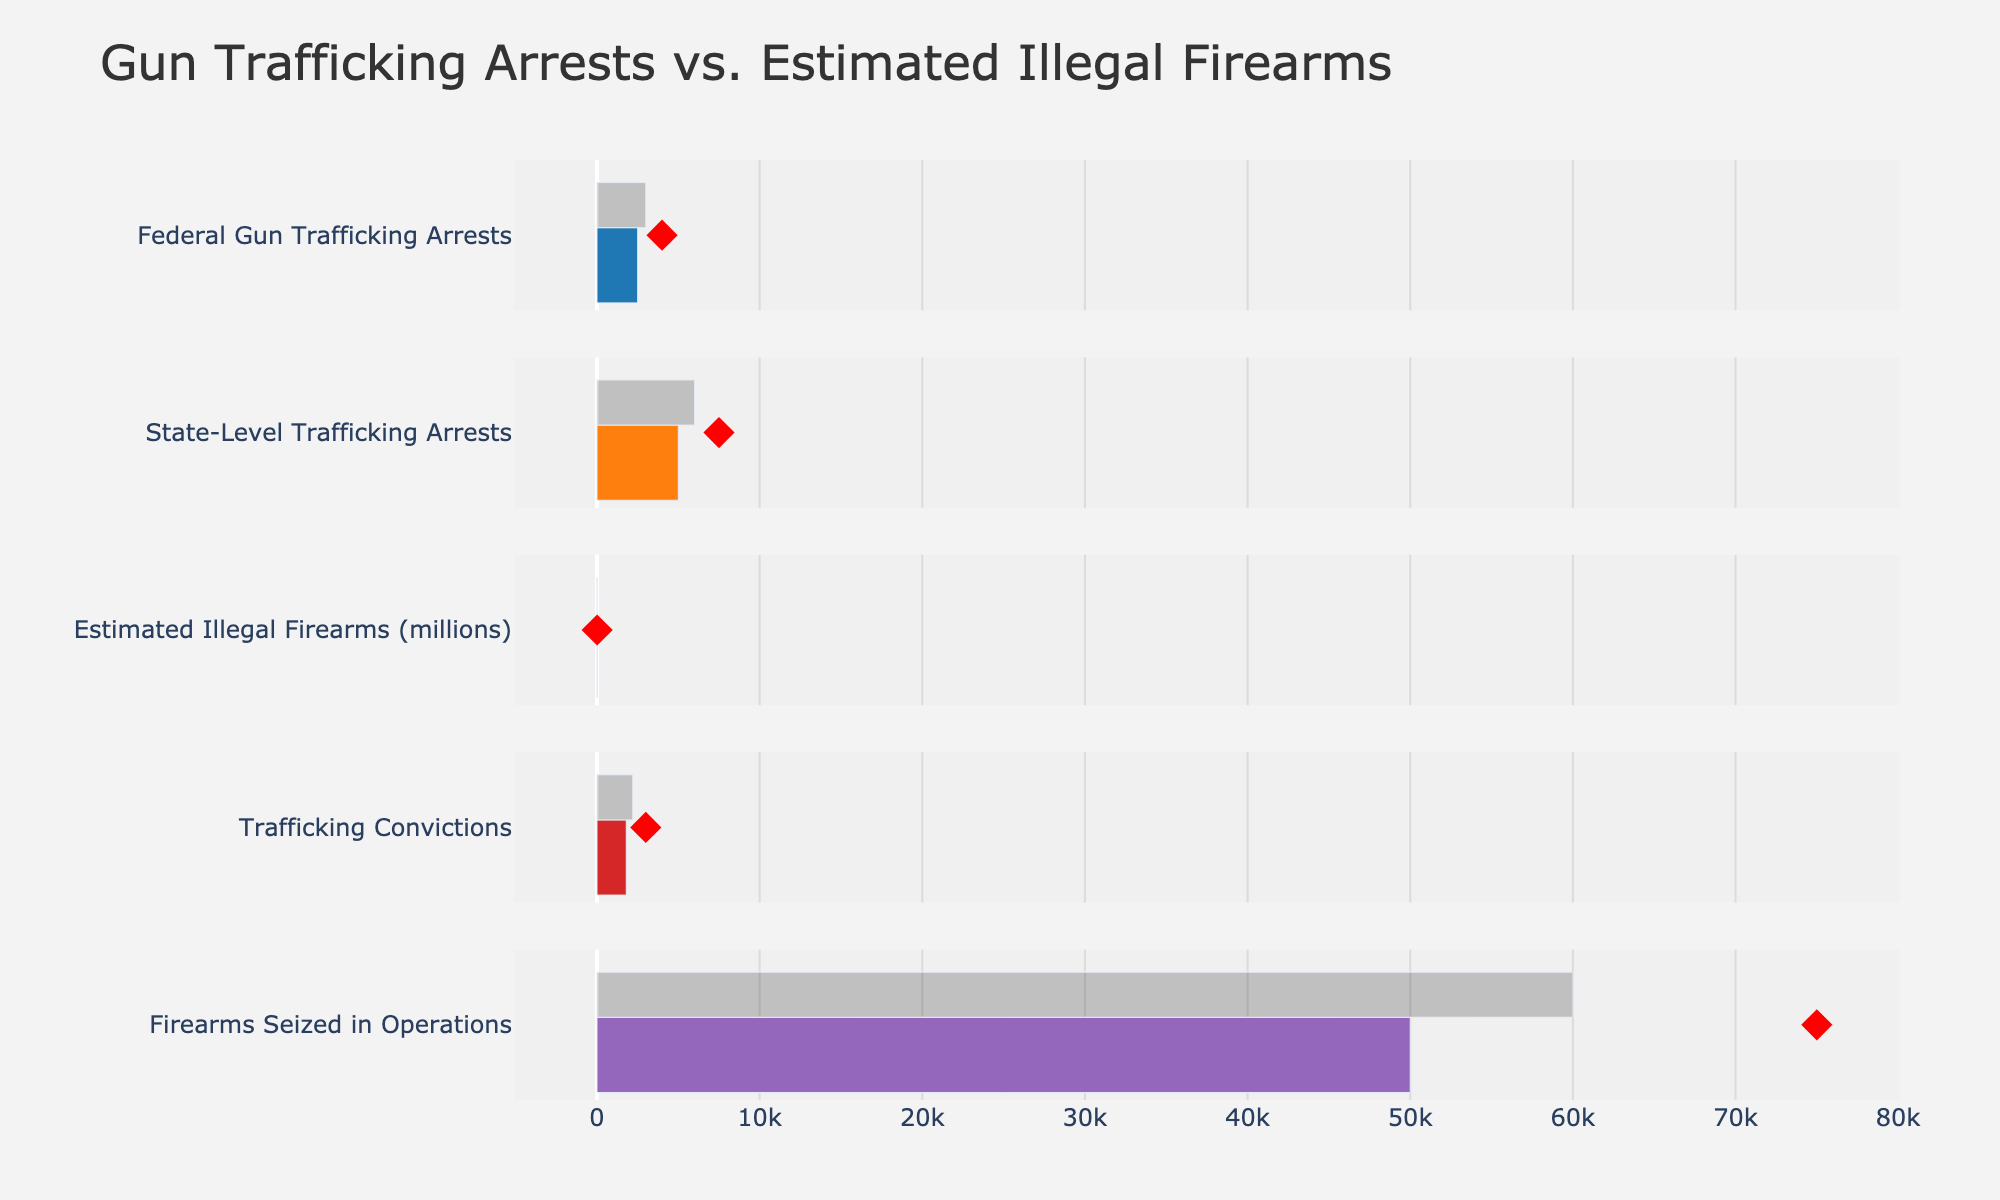what is the title of the figure? The title is displayed at the top of the figure. It's a clear descriptive text for the entire chart.
Answer: Gun Trafficking Arrests vs. Estimated Illegal Firearms Which category has the highest actual value? The actual values are represented by solid bars. The highest solid bar is compared across all categories.
Answer: Estimated Illegal Firearms (millions) What is the target value for Trafficking Convictions? The target values are marked by red diamond symbols. Locate the red diamond in the Trafficking Convictions row.
Answer: 3000 How does the actual number of Federal Gun Trafficking Arrests compare to the target? Compare the solid bar (actual) with the red diamond (target) in the Federal Gun Trafficking Arrests row to see if it is lower, higher, or equal.
Answer: Lower What is the difference between the estimated illegal firearms and the actual number of firearms seized in operations? Subtract the estimated illegal firearms (20 million) from the firearms seized (50,000). Convert units if necessary for an accurate calculation.
Answer: 19,950,000 By how much do state-level trafficking arrests fall short of the target? Subtract the actual state-level trafficking arrests (5,000) from the target (7,500).
Answer: 2,500 Which category has a comparative value higher than its actual value? Check each category to see if the semi-transparent bar (comparative) is longer than the solid bar (actual).
Answer: Federal Gun Trafficking Arrests, State-Level Trafficking Arrests, Trafficking Convictions, Firearms Seized in Operations What is the combined total actual value for all categories? Sum the actual values across all categories: 2,500 (Federal Gun Trafficking Arrests) + 5,000 (State-Level Trafficking Arrests) + 20,000,000 (Estimated Illegal Firearms) + 1,800 (Trafficking Convictions) + 50,000 (Firearms Seized in Operations).
Answer: 20,059,300 Which category shows the largest gap between comparative and actual values? Calculate the difference between comparative and actual values for each category and identify the largest one.
Answer: State-Level Trafficking Arrests Is there any category where the target value is surpassed? Compare each actual value (solid bar) and target value (red diamond) across all categories to see if any actual value exceeds the target.
Answer: No 